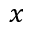Convert formula to latex. <formula><loc_0><loc_0><loc_500><loc_500>x</formula> 